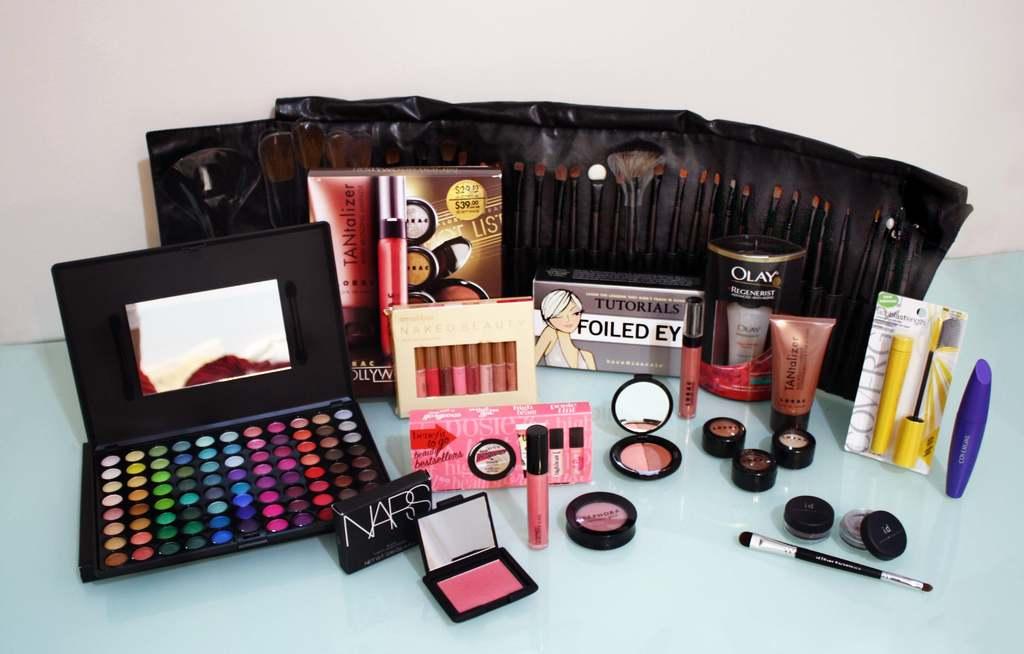What is the brand name on the black case in the front?
Offer a terse response. Nars. How expensive is this makeup set?
Make the answer very short. $39.00. 